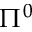<formula> <loc_0><loc_0><loc_500><loc_500>\Pi ^ { 0 }</formula> 